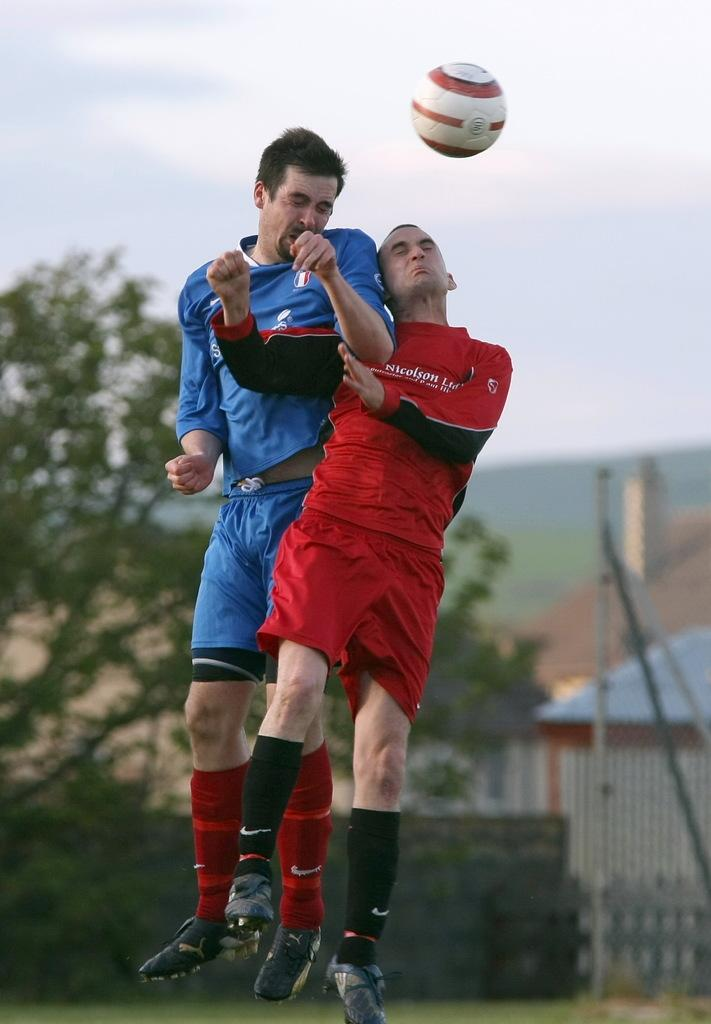What are the men in the image doing? The men in the center of the image are jumping. What can be seen in the background of the image? There are trees, buildings, a hill, and the sky visible in the background of the image. What time of day is depicted in the image? The time of day cannot be determined from the image, as there are no specific indicators of time. 